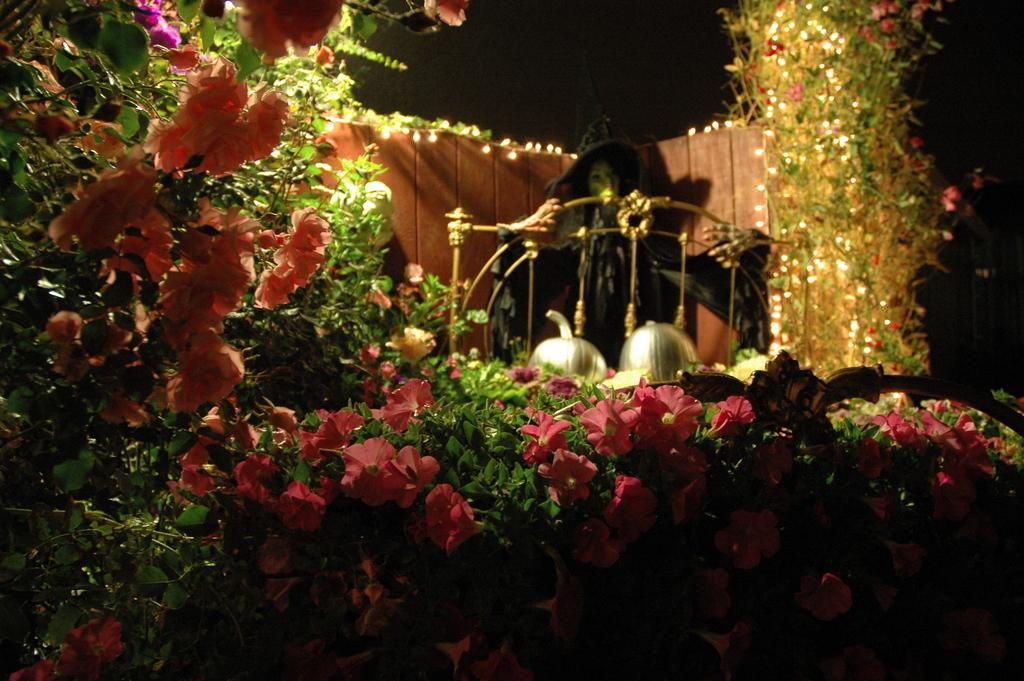What type of flora is present in the image? There are colorful flowers and plants in the image. What can be seen illuminating the scene in the image? There are lights in the image. What type of toy is present in the image? There is a black color toy in the image. What colors are present in the objects in the image? There are silver and gold color objects in the image. How would you describe the background of the image? The background of the image is dark. How many sheep are visible in the image? There are no sheep present in the image. What type of hair is shown on the plants in the image? The plants in the image do not have hair; they are not animals. 